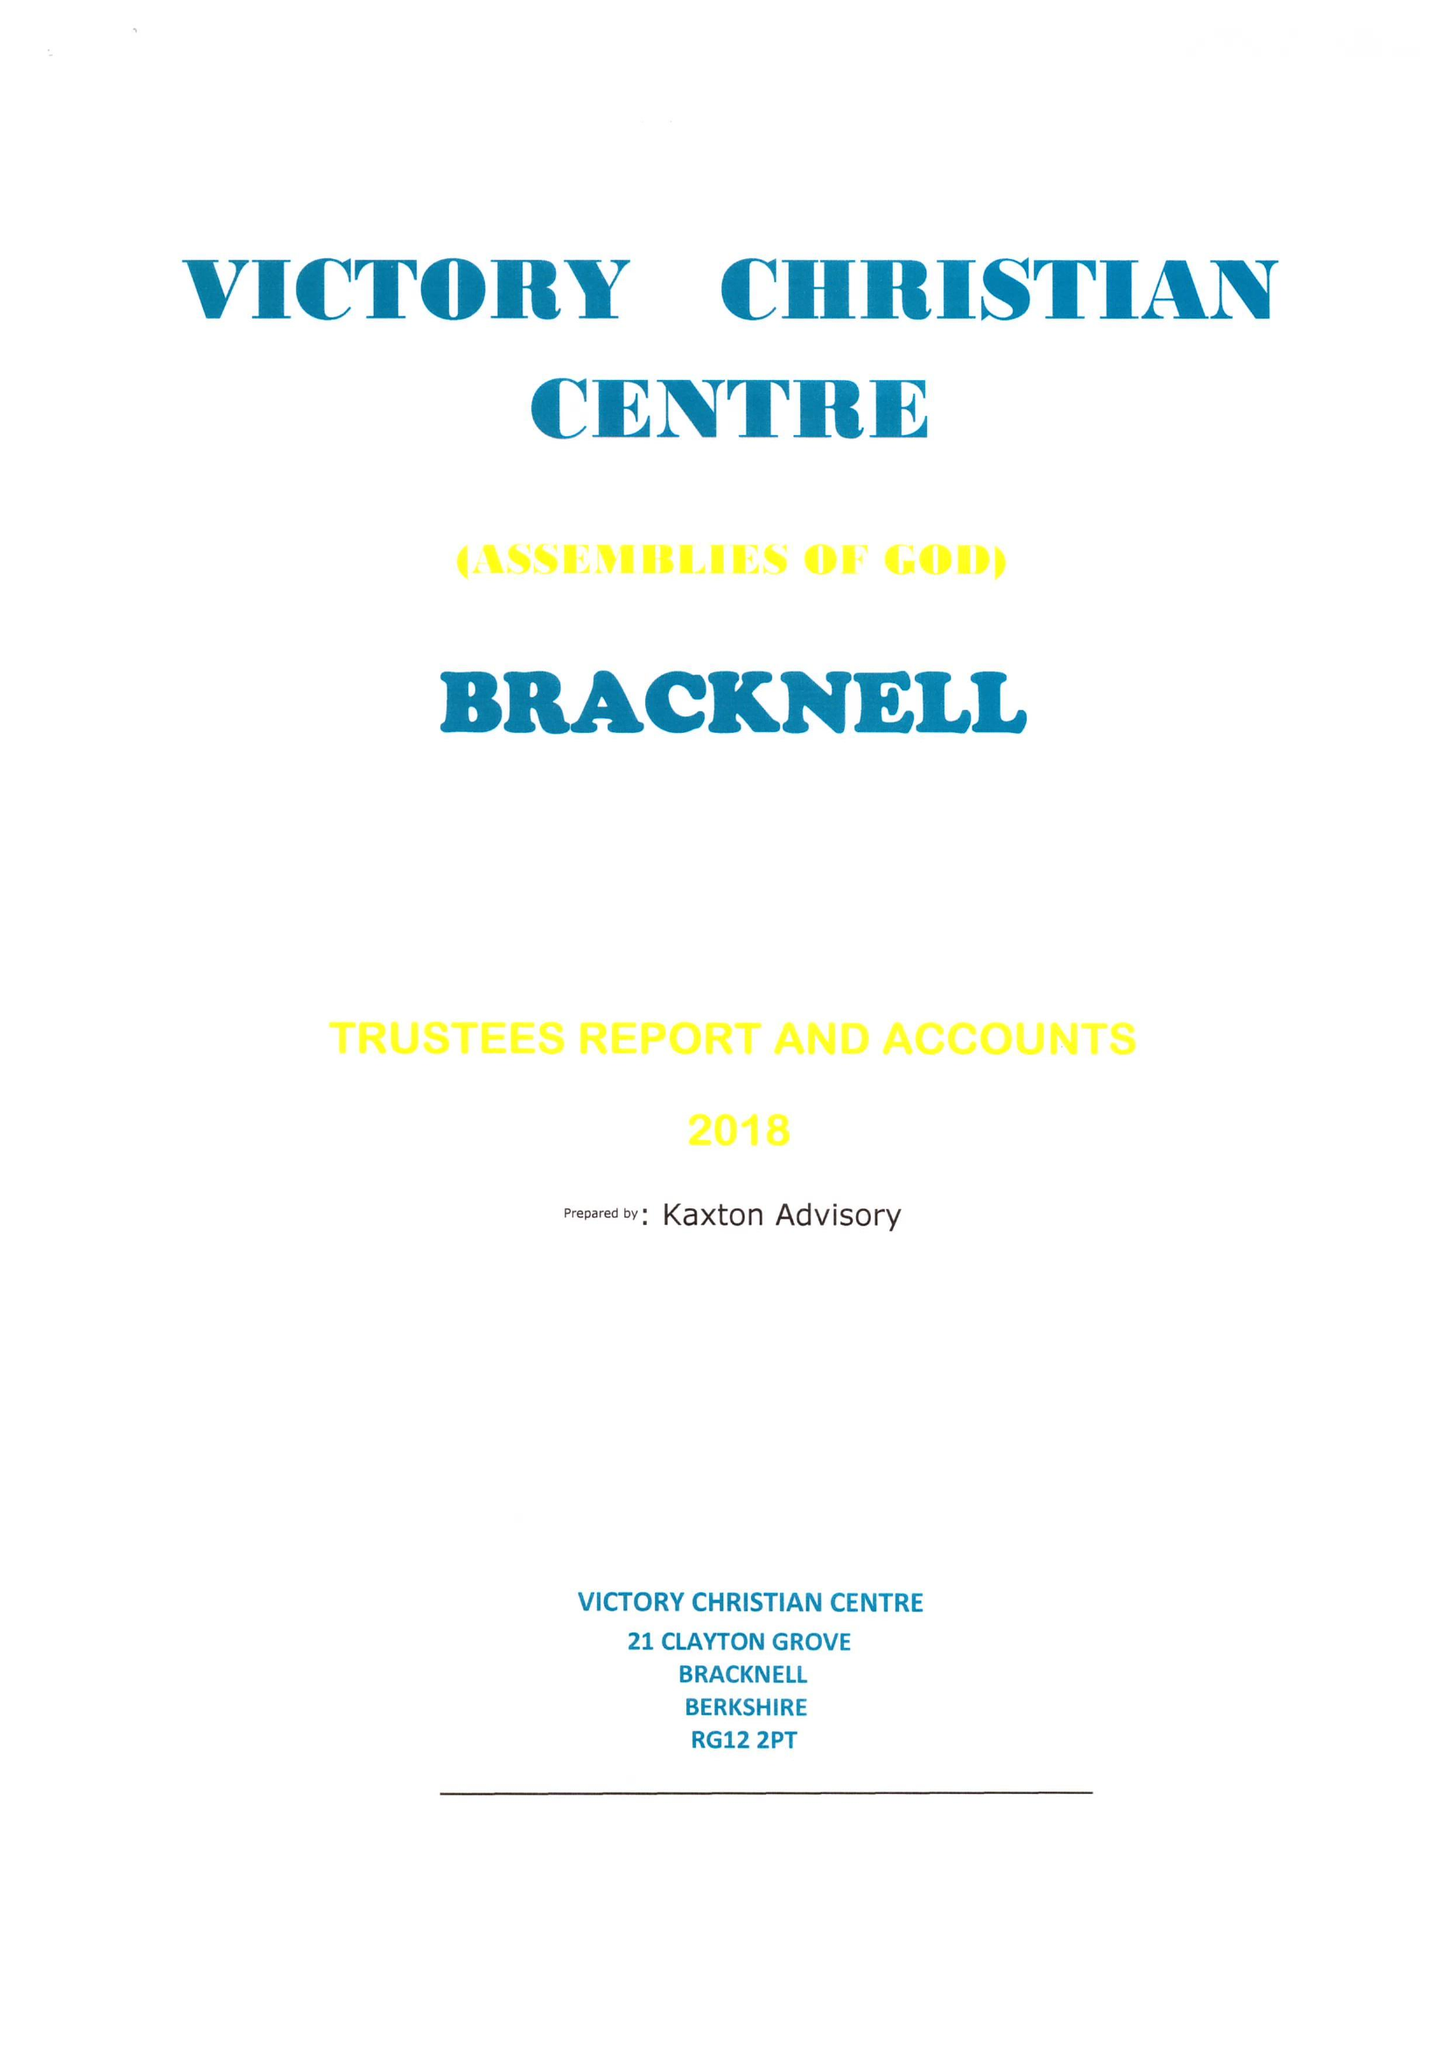What is the value for the spending_annually_in_british_pounds?
Answer the question using a single word or phrase. 39267.00 